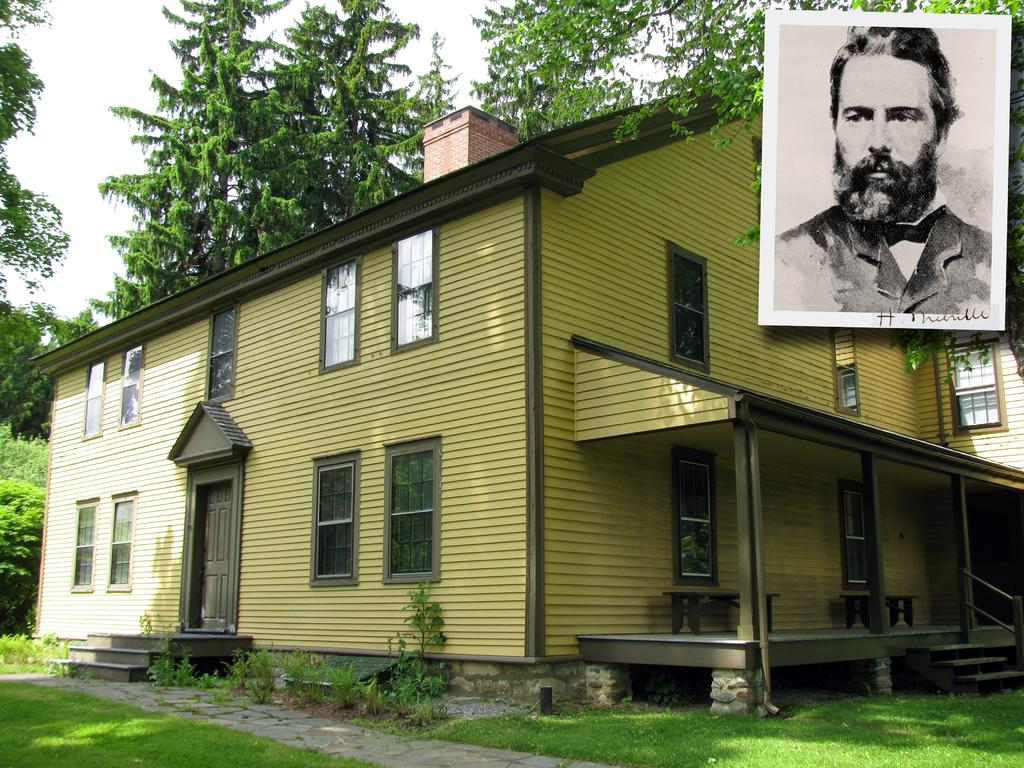What type of landscape is depicted in the image? There is a grassland in the image. What structures can be seen in the background of the image? There is a house and trees in the background of the image. What is visible in the sky in the image? The sky is visible in the background of the image. Where is the photo of a man located in the image? The photo of a man is in the top right corner of the image. How does the grassland reason in the image? Grasslands do not have the ability to reason; they are a type of landscape. 